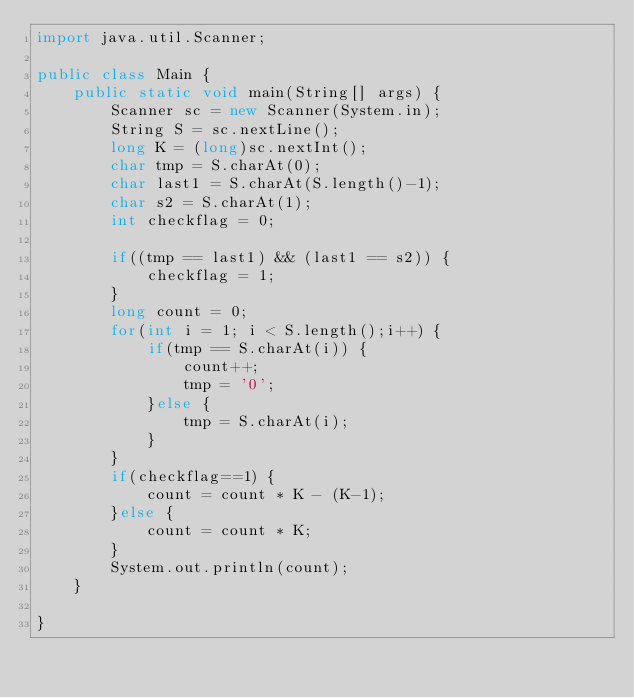<code> <loc_0><loc_0><loc_500><loc_500><_Java_>import java.util.Scanner;

public class Main {
	public static void main(String[] args) {
		Scanner sc = new Scanner(System.in);
		String S = sc.nextLine();
		long K = (long)sc.nextInt();
		char tmp = S.charAt(0);
		char last1 = S.charAt(S.length()-1);
		char s2 = S.charAt(1);
		int checkflag = 0;

		if((tmp == last1) && (last1 == s2)) {
			checkflag = 1;
		}
		long count = 0;
		for(int i = 1; i < S.length();i++) {
			if(tmp == S.charAt(i)) {
				count++;
				tmp = '0';
			}else {
				tmp = S.charAt(i);
			}
		}
		if(checkflag==1) {
			count = count * K - (K-1);
		}else {
			count = count * K;
		}
		System.out.println(count);
	}

}

</code> 